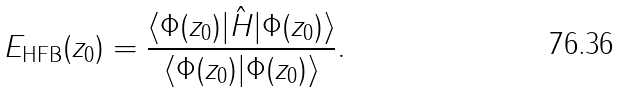<formula> <loc_0><loc_0><loc_500><loc_500>E _ { \text {HFB} } ( z _ { 0 } ) = \frac { \langle \Phi ( z _ { 0 } ) | \hat { H } | \Phi ( z _ { 0 } ) \rangle } { \langle \Phi ( z _ { 0 } ) | \Phi ( z _ { 0 } ) \rangle } .</formula> 